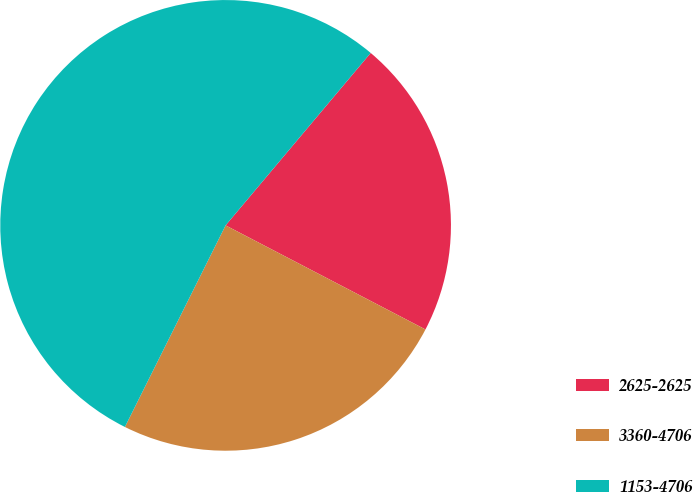Convert chart to OTSL. <chart><loc_0><loc_0><loc_500><loc_500><pie_chart><fcel>2625-2625<fcel>3360-4706<fcel>1153-4706<nl><fcel>21.51%<fcel>24.73%<fcel>53.76%<nl></chart> 